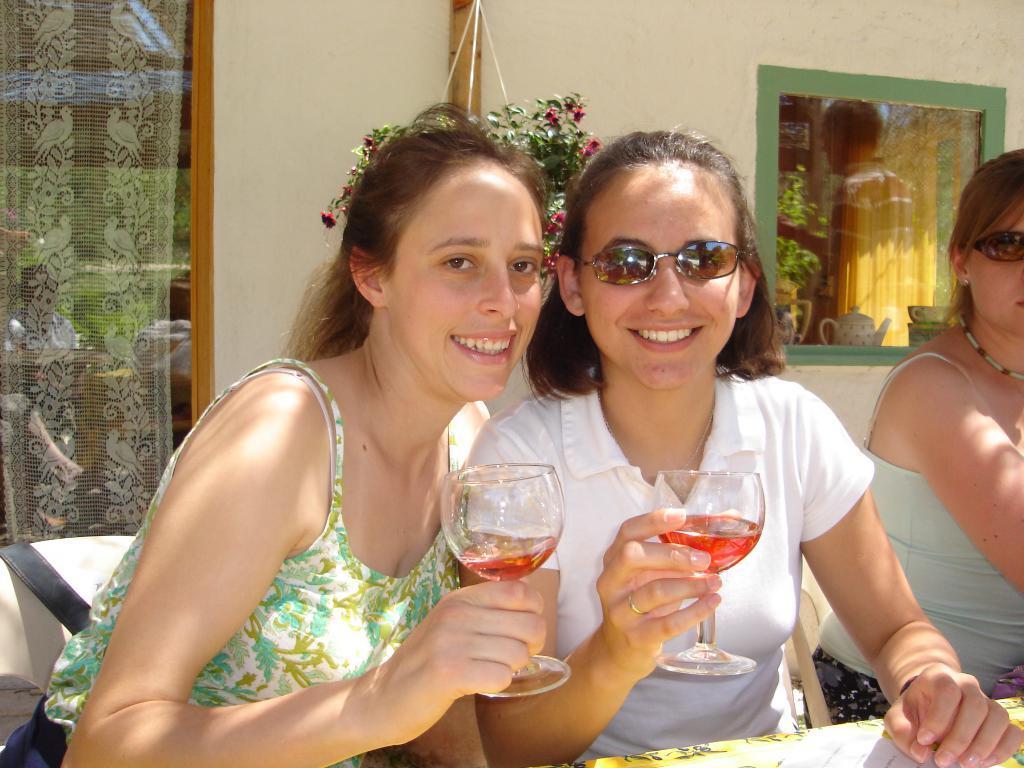Can you describe this image briefly? In this picture we can see three persons and in front this two persons holding glasses in their hands with drink in it and smiling and in background we can see glass, wall, window, tea pot, flower pot with plant. 